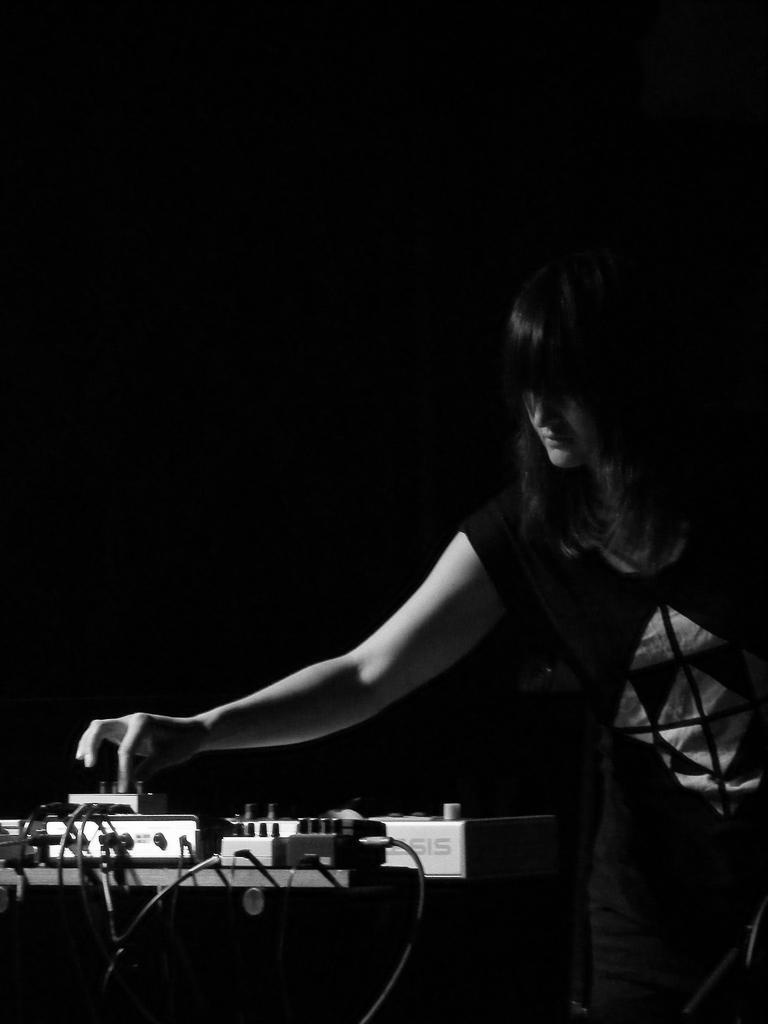In one or two sentences, can you explain what this image depicts? As we can see in the image there is a woman wearing black color dress and table. On table there are switch boards. The image is little dark. 